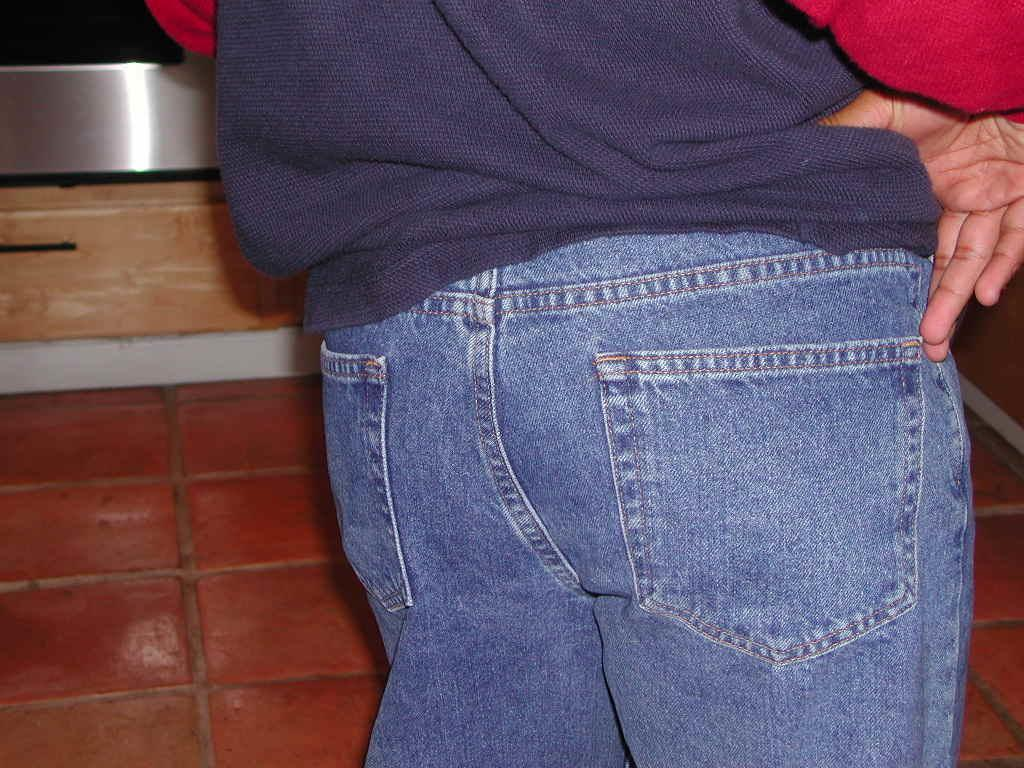What is present in the image? There is a person in the image. Can you describe the person's clothing? The person is wearing a dress with purple, blue, and red colors. What can be seen in the background of the image? There is a brown color surface in the background of the image. What type of cap is the carpenter wearing in the image? There is no carpenter or cap present in the image; it features a person wearing a dress. How many rings can be seen on the person's fingers in the image? There is no mention of rings in the image; the person is wearing a dress with purple, blue, and red colors. 